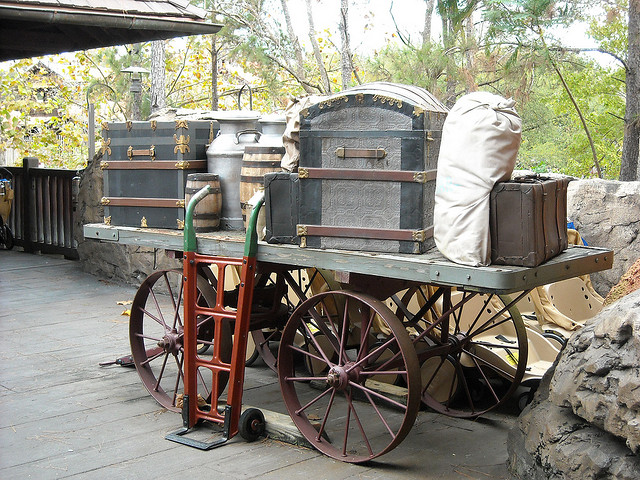Could you describe the surroundings of the wagon? The wagon is positioned on what looks to be a wooden platform, and there's vegetation visible in the background. The setting evokes a rustic outdoor ambiance, perhaps a part of a historical park or a themed exhibit that recreates the look and feel of an earlier time. 